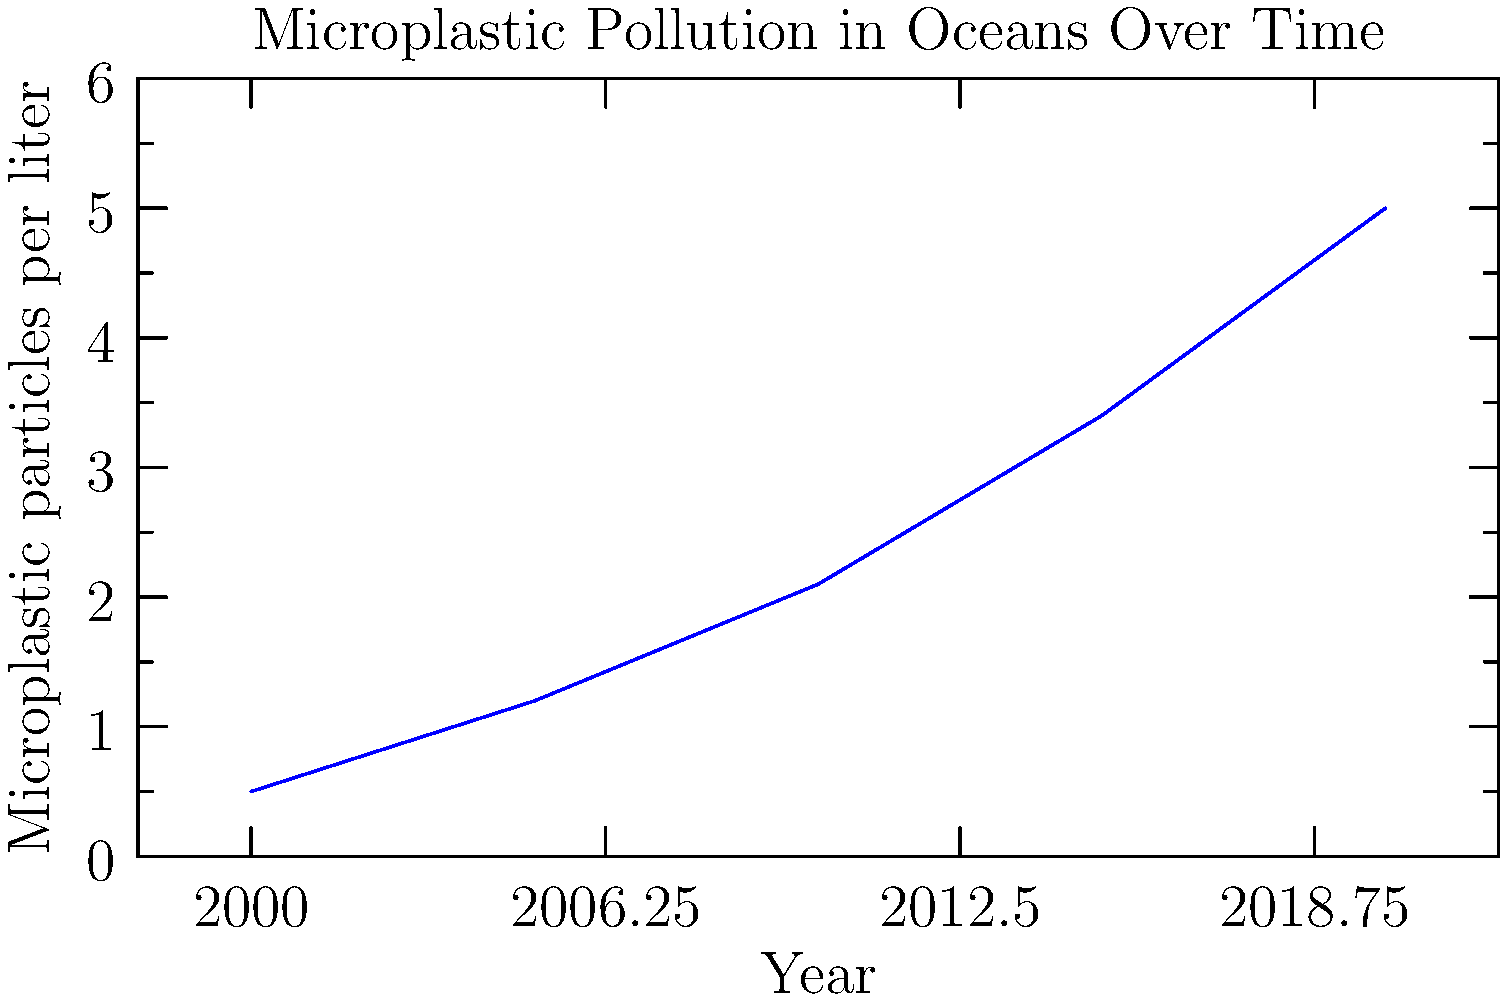Based on the line graph showing the trend of microplastic pollution in oceans from 2000 to 2020, calculate the average rate of increase in microplastic particles per liter per year. Round your answer to two decimal places. To calculate the average rate of increase in microplastic particles per liter per year:

1. Calculate the total increase:
   Final value (2020) - Initial value (2000) = 5.0 - 0.5 = 4.5 particles/liter

2. Calculate the time period:
   2020 - 2000 = 20 years

3. Calculate the average rate of increase per year:
   $\frac{\text{Total increase}}{\text{Time period}} = \frac{4.5 \text{ particles/liter}}{20 \text{ years}}$

4. Perform the division:
   $\frac{4.5}{20} = 0.225 \text{ particles/liter/year}$

5. Round to two decimal places:
   0.23 particles/liter/year

Therefore, the average rate of increase in microplastic particles per liter per year is 0.23 particles/liter/year.
Answer: 0.23 particles/liter/year 